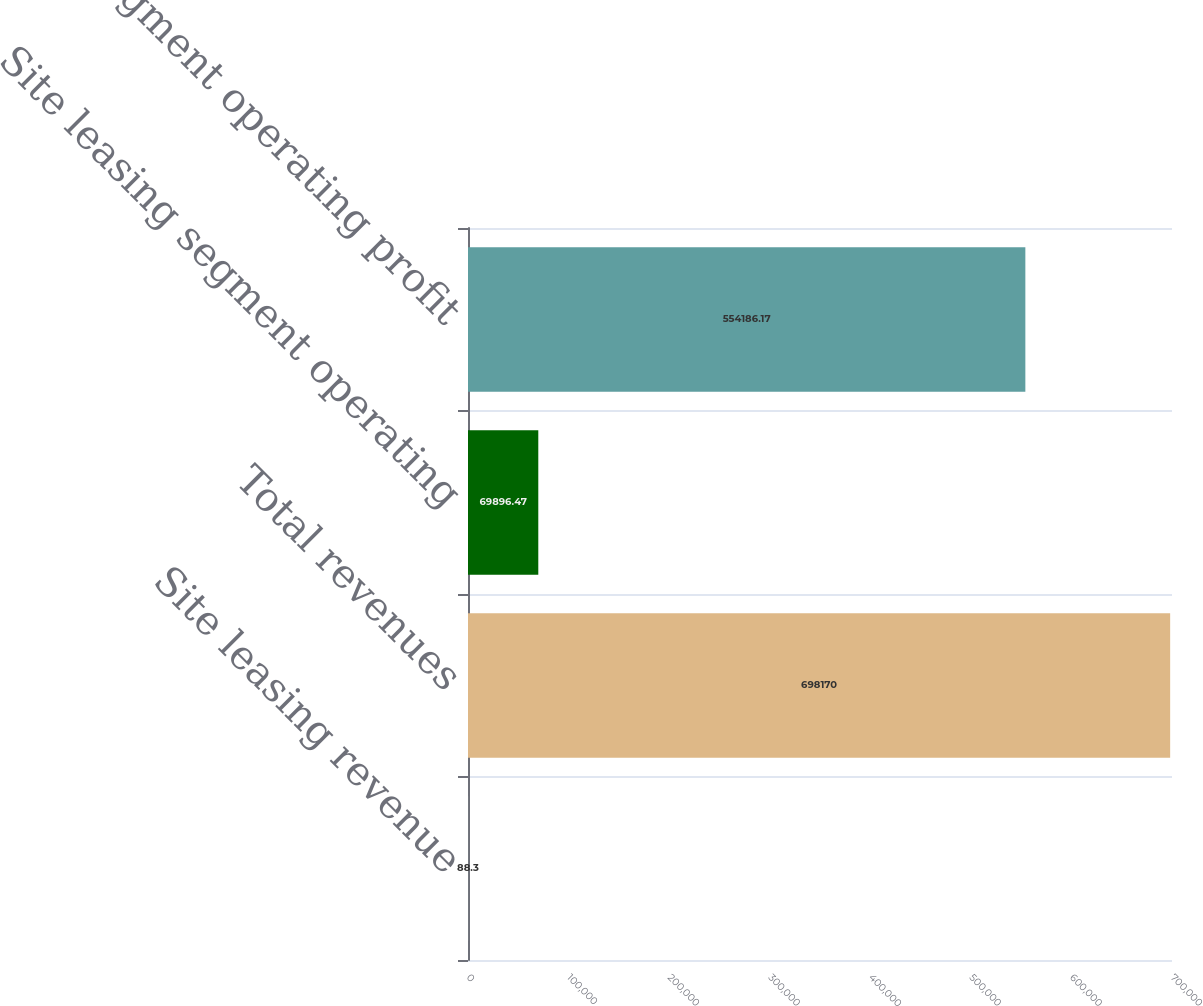Convert chart to OTSL. <chart><loc_0><loc_0><loc_500><loc_500><bar_chart><fcel>Site leasing revenue<fcel>Total revenues<fcel>Site leasing segment operating<fcel>Total segment operating profit<nl><fcel>88.3<fcel>698170<fcel>69896.5<fcel>554186<nl></chart> 